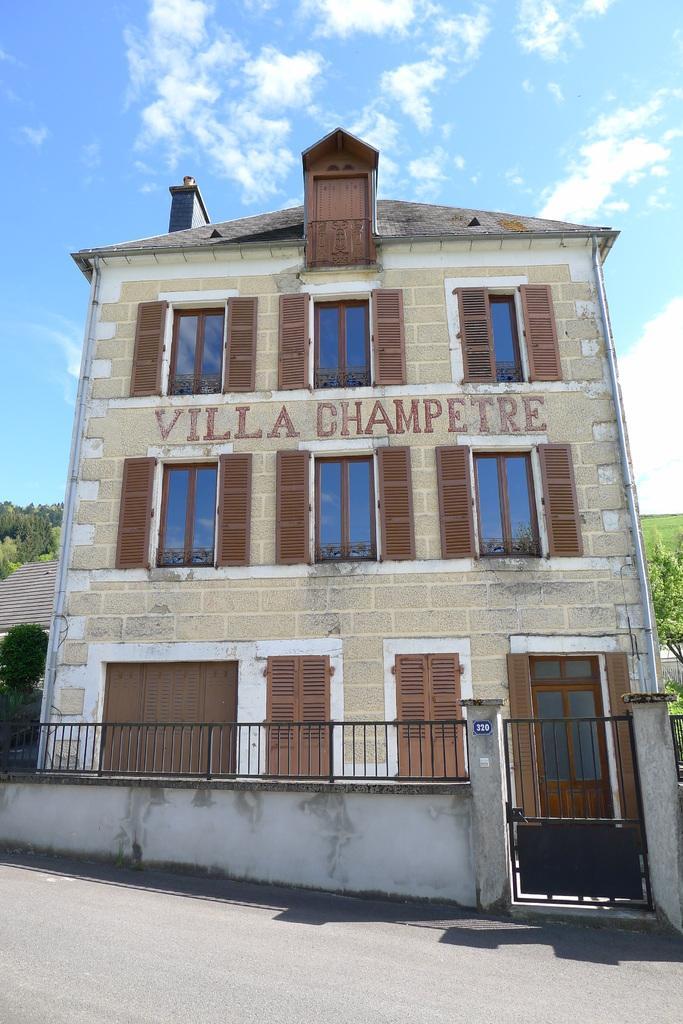Describe this image in one or two sentences. This picture shows a building and we see a wall with a metal gate and we see trees and house on the side and we see a blue cloudy sky. 